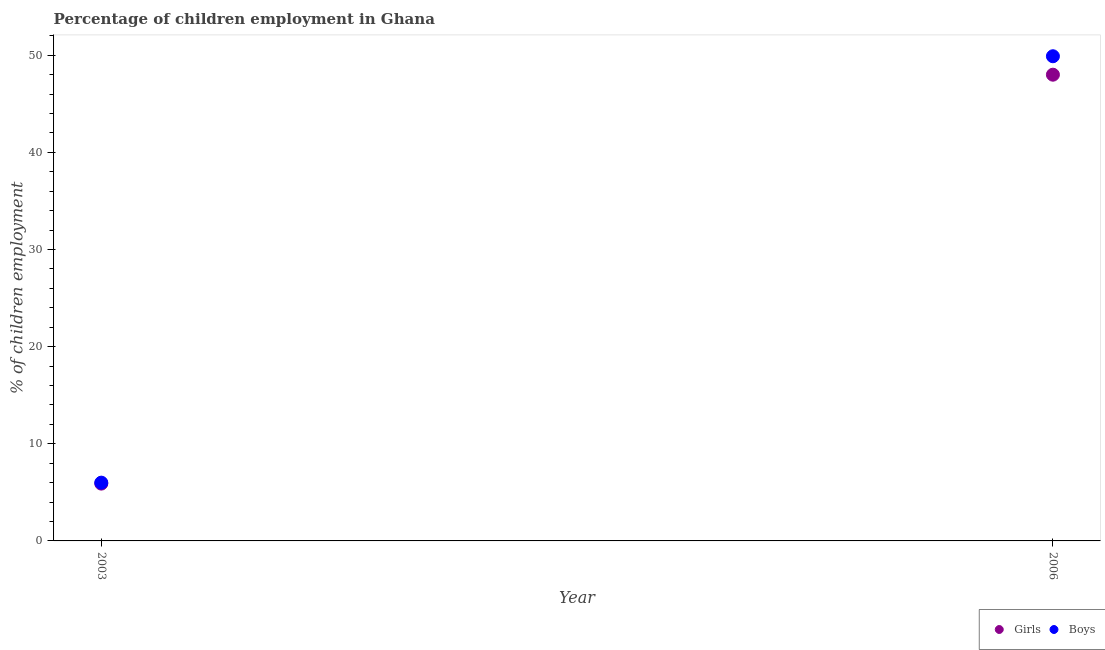Is the number of dotlines equal to the number of legend labels?
Your response must be concise. Yes. Across all years, what is the maximum percentage of employed girls?
Your response must be concise. 48. Across all years, what is the minimum percentage of employed girls?
Ensure brevity in your answer.  5.9. What is the total percentage of employed girls in the graph?
Give a very brief answer. 53.9. What is the difference between the percentage of employed girls in 2003 and that in 2006?
Provide a succinct answer. -42.1. What is the difference between the percentage of employed girls in 2003 and the percentage of employed boys in 2006?
Keep it short and to the point. -44. What is the average percentage of employed girls per year?
Offer a very short reply. 26.95. In the year 2003, what is the difference between the percentage of employed girls and percentage of employed boys?
Provide a succinct answer. -0.1. In how many years, is the percentage of employed girls greater than 50 %?
Your answer should be compact. 0. What is the ratio of the percentage of employed boys in 2003 to that in 2006?
Give a very brief answer. 0.12. What is the difference between two consecutive major ticks on the Y-axis?
Your response must be concise. 10. Does the graph contain any zero values?
Provide a succinct answer. No. Does the graph contain grids?
Make the answer very short. No. Where does the legend appear in the graph?
Your answer should be very brief. Bottom right. How many legend labels are there?
Give a very brief answer. 2. How are the legend labels stacked?
Provide a succinct answer. Horizontal. What is the title of the graph?
Your answer should be very brief. Percentage of children employment in Ghana. Does "Male labor force" appear as one of the legend labels in the graph?
Provide a succinct answer. No. What is the label or title of the X-axis?
Provide a succinct answer. Year. What is the label or title of the Y-axis?
Make the answer very short. % of children employment. What is the % of children employment of Boys in 2003?
Keep it short and to the point. 6. What is the % of children employment of Girls in 2006?
Give a very brief answer. 48. What is the % of children employment of Boys in 2006?
Your answer should be very brief. 49.9. Across all years, what is the maximum % of children employment in Girls?
Provide a short and direct response. 48. Across all years, what is the maximum % of children employment of Boys?
Offer a very short reply. 49.9. Across all years, what is the minimum % of children employment in Boys?
Ensure brevity in your answer.  6. What is the total % of children employment of Girls in the graph?
Provide a short and direct response. 53.9. What is the total % of children employment of Boys in the graph?
Offer a very short reply. 55.9. What is the difference between the % of children employment of Girls in 2003 and that in 2006?
Your answer should be compact. -42.1. What is the difference between the % of children employment of Boys in 2003 and that in 2006?
Keep it short and to the point. -43.9. What is the difference between the % of children employment in Girls in 2003 and the % of children employment in Boys in 2006?
Provide a short and direct response. -44. What is the average % of children employment in Girls per year?
Your response must be concise. 26.95. What is the average % of children employment of Boys per year?
Keep it short and to the point. 27.95. In the year 2006, what is the difference between the % of children employment of Girls and % of children employment of Boys?
Your response must be concise. -1.9. What is the ratio of the % of children employment of Girls in 2003 to that in 2006?
Your answer should be compact. 0.12. What is the ratio of the % of children employment of Boys in 2003 to that in 2006?
Your answer should be very brief. 0.12. What is the difference between the highest and the second highest % of children employment in Girls?
Provide a short and direct response. 42.1. What is the difference between the highest and the second highest % of children employment in Boys?
Offer a terse response. 43.9. What is the difference between the highest and the lowest % of children employment in Girls?
Offer a terse response. 42.1. What is the difference between the highest and the lowest % of children employment of Boys?
Your answer should be compact. 43.9. 